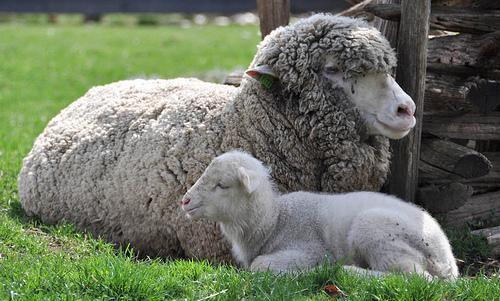How many animals are pictured?
Give a very brief answer. 2. 